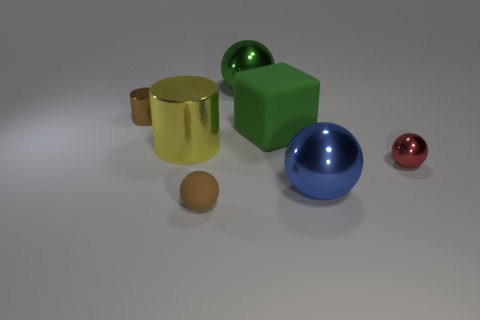There is a small thing that is the same color as the tiny matte ball; what is it made of?
Offer a terse response. Metal. There is a green metal ball; is its size the same as the brown object that is behind the yellow object?
Provide a succinct answer. No. Is there a shiny thing that has the same color as the big matte cube?
Provide a short and direct response. Yes. Are there any other things that have the same shape as the brown metallic thing?
Keep it short and to the point. Yes. What shape is the big object that is both in front of the matte cube and left of the big green block?
Ensure brevity in your answer.  Cylinder. What number of small brown objects are the same material as the large yellow cylinder?
Offer a very short reply. 1. Are there fewer cylinders that are behind the tiny metal sphere than green metallic objects?
Give a very brief answer. No. Are there any objects on the left side of the shiny object that is to the right of the big blue thing?
Provide a short and direct response. Yes. Is there any other thing that has the same shape as the large green rubber object?
Provide a short and direct response. No. Is the brown matte sphere the same size as the green matte thing?
Your response must be concise. No. 